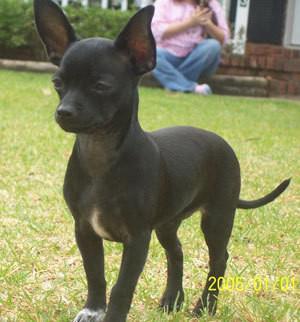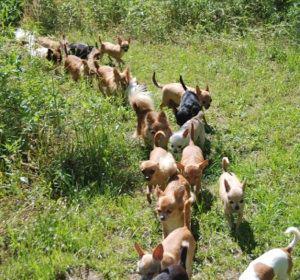The first image is the image on the left, the second image is the image on the right. Given the left and right images, does the statement "The right image contains at least two chihuahua's." hold true? Answer yes or no. Yes. The first image is the image on the left, the second image is the image on the right. Evaluate the accuracy of this statement regarding the images: "There are three dogs shown". Is it true? Answer yes or no. No. 